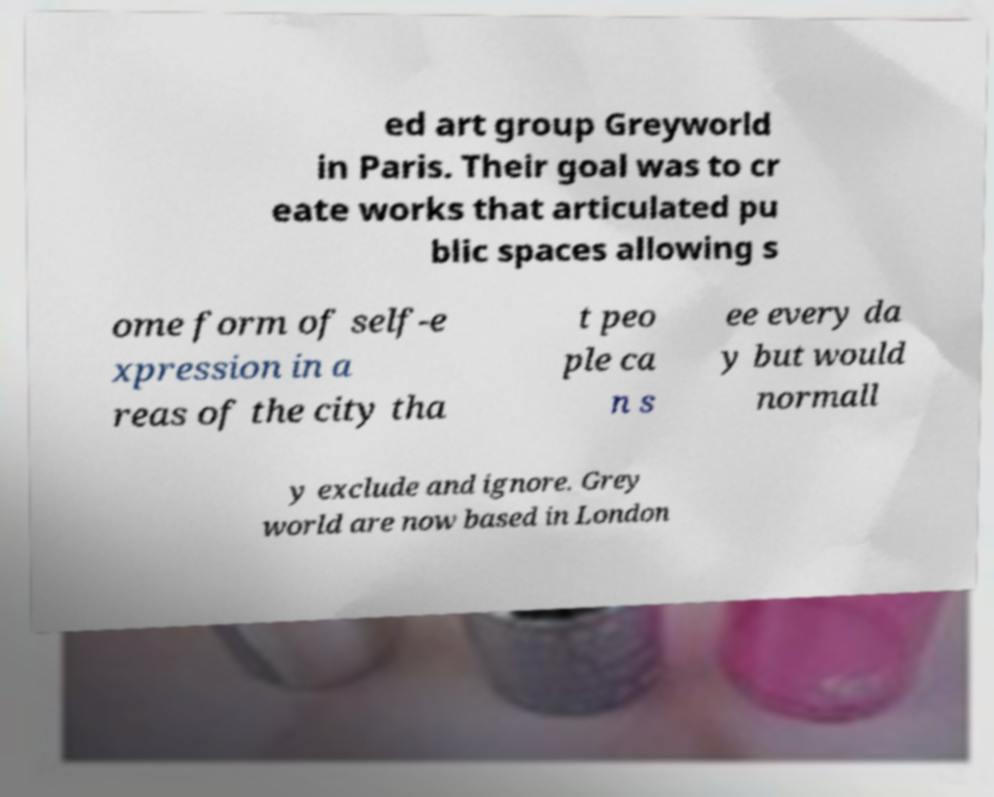For documentation purposes, I need the text within this image transcribed. Could you provide that? ed art group Greyworld in Paris. Their goal was to cr eate works that articulated pu blic spaces allowing s ome form of self-e xpression in a reas of the city tha t peo ple ca n s ee every da y but would normall y exclude and ignore. Grey world are now based in London 